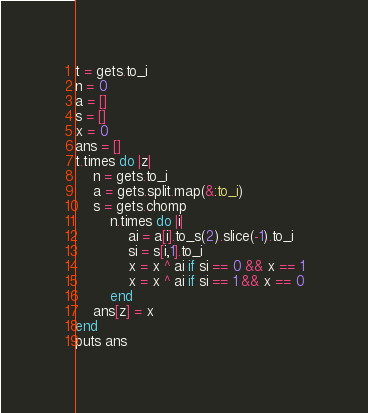Convert code to text. <code><loc_0><loc_0><loc_500><loc_500><_Ruby_>t = gets.to_i
n = 0
a = []
s = []
x = 0
ans = []
t.times do |z|
	n = gets.to_i
	a = gets.split.map(&:to_i)
	s = gets.chomp
		n.times do |i|
			ai = a[i].to_s(2).slice(-1).to_i
			si = s[i,1].to_i
			x = x ^ ai if si == 0 && x == 1
			x = x ^ ai if si == 1 && x == 0
		end
	ans[z] = x
end
puts ans</code> 